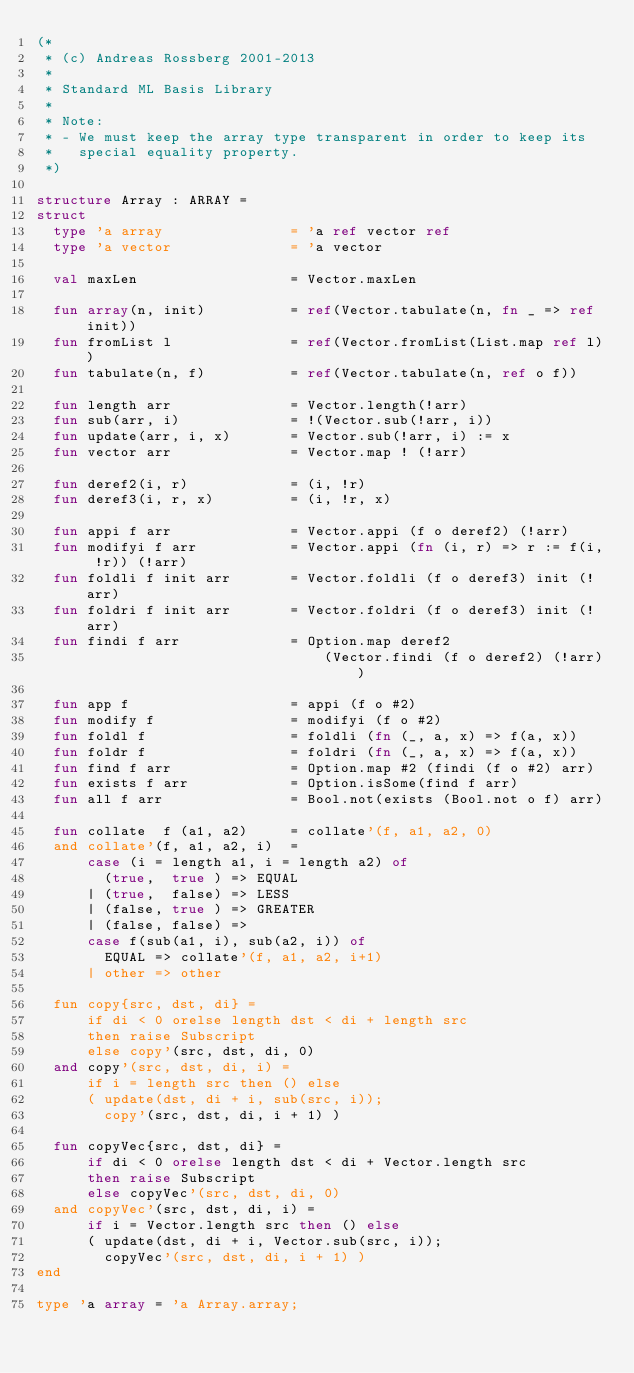<code> <loc_0><loc_0><loc_500><loc_500><_SML_>(*
 * (c) Andreas Rossberg 2001-2013
 *
 * Standard ML Basis Library
 *
 * Note:
 * - We must keep the array type transparent in order to keep its
 *   special equality property.
 *)

structure Array : ARRAY =
struct
  type 'a array               = 'a ref vector ref
  type 'a vector              = 'a vector

  val maxLen                  = Vector.maxLen

  fun array(n, init)          = ref(Vector.tabulate(n, fn _ => ref init))
  fun fromList l              = ref(Vector.fromList(List.map ref l))
  fun tabulate(n, f)          = ref(Vector.tabulate(n, ref o f))

  fun length arr              = Vector.length(!arr)
  fun sub(arr, i)             = !(Vector.sub(!arr, i))
  fun update(arr, i, x)       = Vector.sub(!arr, i) := x
  fun vector arr              = Vector.map ! (!arr)

  fun deref2(i, r)            = (i, !r)
  fun deref3(i, r, x)         = (i, !r, x)

  fun appi f arr              = Vector.appi (f o deref2) (!arr)
  fun modifyi f arr           = Vector.appi (fn (i, r) => r := f(i, !r)) (!arr)
  fun foldli f init arr       = Vector.foldli (f o deref3) init (!arr)
  fun foldri f init arr       = Vector.foldri (f o deref3) init (!arr)
  fun findi f arr             = Option.map deref2
                                  (Vector.findi (f o deref2) (!arr))

  fun app f                   = appi (f o #2)
  fun modify f                = modifyi (f o #2)
  fun foldl f                 = foldli (fn (_, a, x) => f(a, x))
  fun foldr f                 = foldri (fn (_, a, x) => f(a, x))
  fun find f arr              = Option.map #2 (findi (f o #2) arr)
  fun exists f arr            = Option.isSome(find f arr)
  fun all f arr               = Bool.not(exists (Bool.not o f) arr)

  fun collate  f (a1, a2)     = collate'(f, a1, a2, 0)
  and collate'(f, a1, a2, i)  =
      case (i = length a1, i = length a2) of
        (true,  true ) => EQUAL
      | (true,  false) => LESS
      | (false, true ) => GREATER
      | (false, false) =>
      case f(sub(a1, i), sub(a2, i)) of
        EQUAL => collate'(f, a1, a2, i+1)
      | other => other

  fun copy{src, dst, di} =
      if di < 0 orelse length dst < di + length src
      then raise Subscript
      else copy'(src, dst, di, 0)
  and copy'(src, dst, di, i) =
      if i = length src then () else
      ( update(dst, di + i, sub(src, i));
        copy'(src, dst, di, i + 1) )

  fun copyVec{src, dst, di} =
      if di < 0 orelse length dst < di + Vector.length src
      then raise Subscript
      else copyVec'(src, dst, di, 0)
  and copyVec'(src, dst, di, i) =
      if i = Vector.length src then () else
      ( update(dst, di + i, Vector.sub(src, i));
        copyVec'(src, dst, di, i + 1) )
end

type 'a array = 'a Array.array;
</code> 